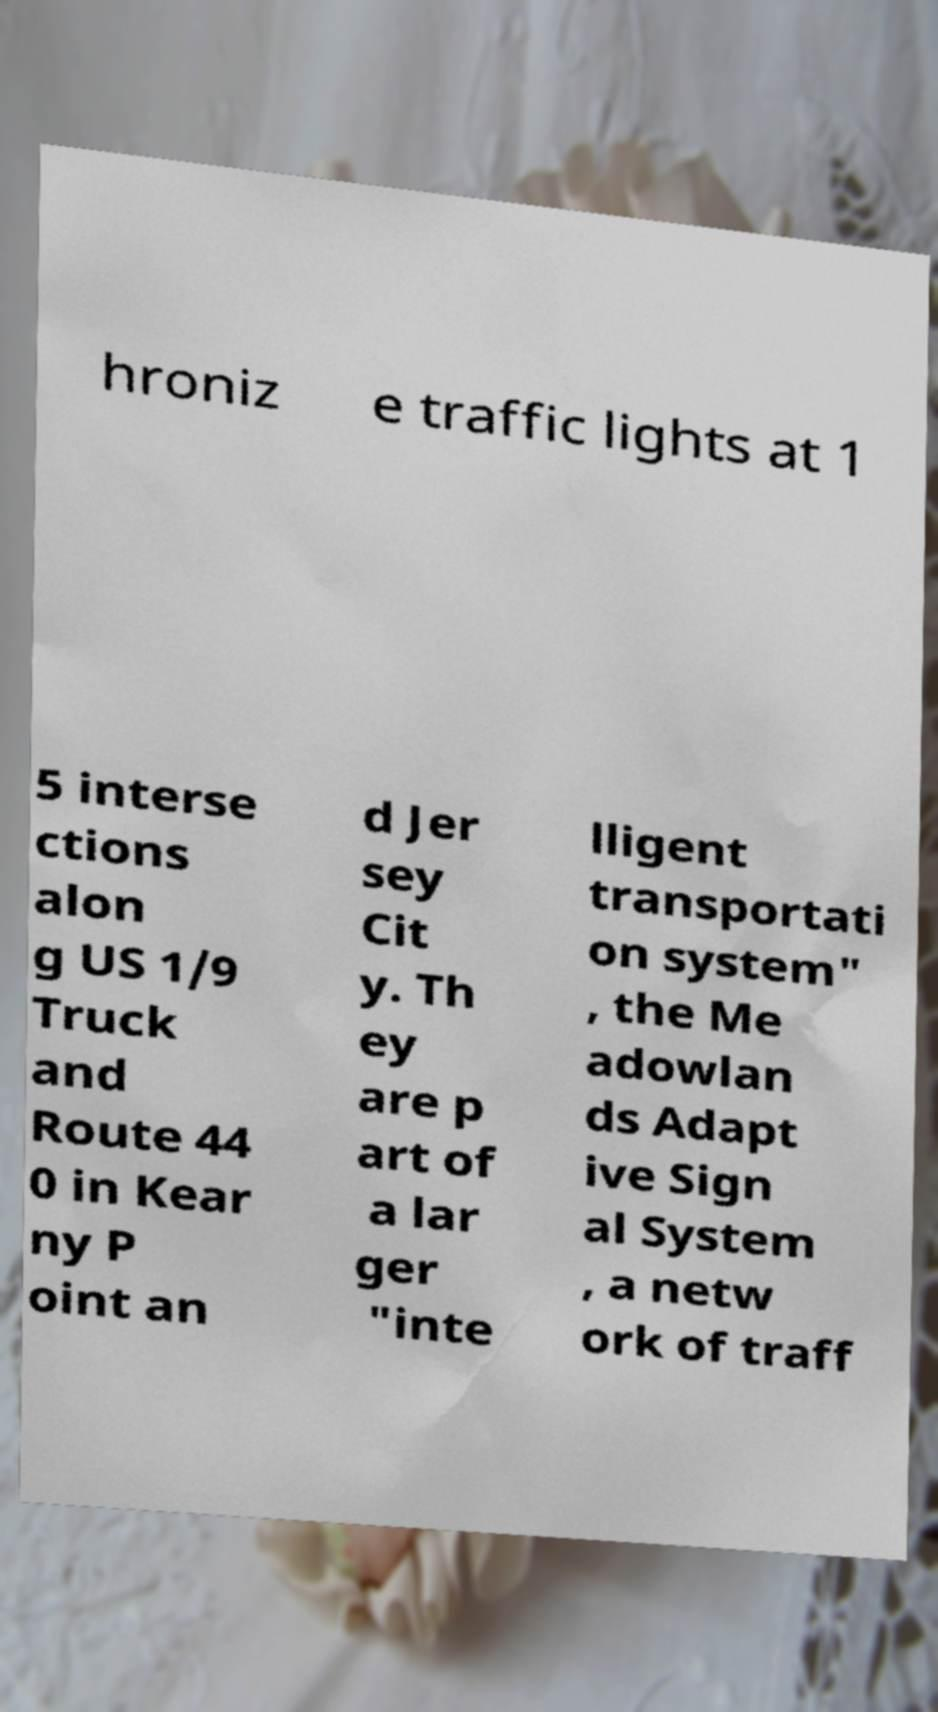Can you read and provide the text displayed in the image?This photo seems to have some interesting text. Can you extract and type it out for me? hroniz e traffic lights at 1 5 interse ctions alon g US 1/9 Truck and Route 44 0 in Kear ny P oint an d Jer sey Cit y. Th ey are p art of a lar ger "inte lligent transportati on system" , the Me adowlan ds Adapt ive Sign al System , a netw ork of traff 